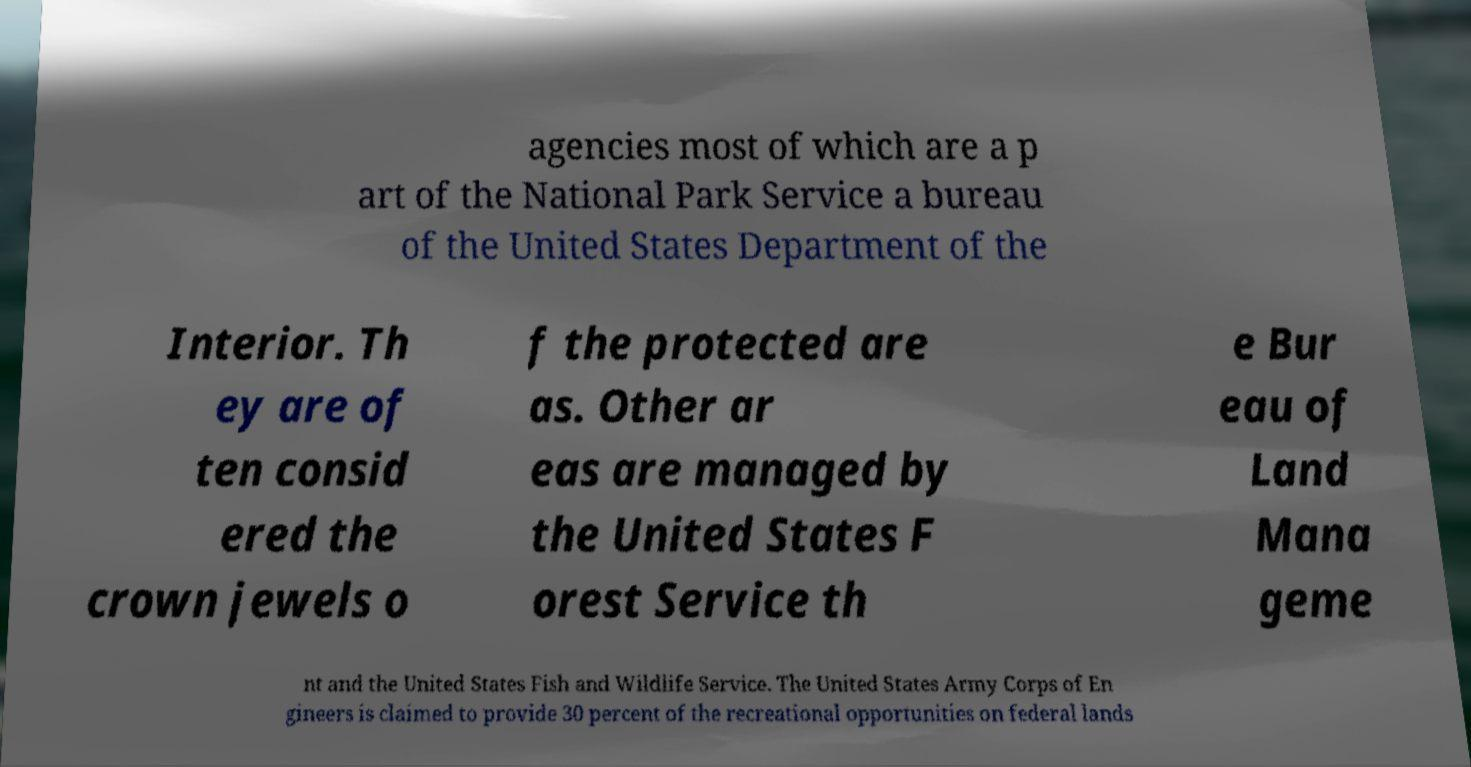There's text embedded in this image that I need extracted. Can you transcribe it verbatim? agencies most of which are a p art of the National Park Service a bureau of the United States Department of the Interior. Th ey are of ten consid ered the crown jewels o f the protected are as. Other ar eas are managed by the United States F orest Service th e Bur eau of Land Mana geme nt and the United States Fish and Wildlife Service. The United States Army Corps of En gineers is claimed to provide 30 percent of the recreational opportunities on federal lands 